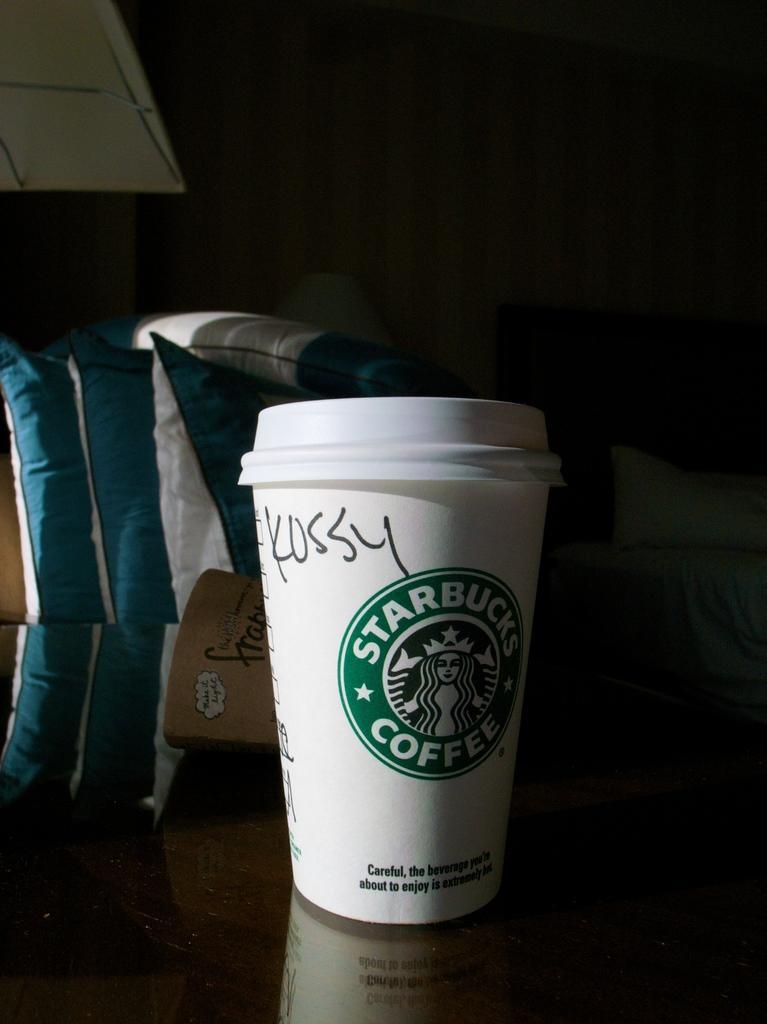Can you describe this image briefly? We can able to see a cup and pillows. Beside this table there is a bed with pillow. 